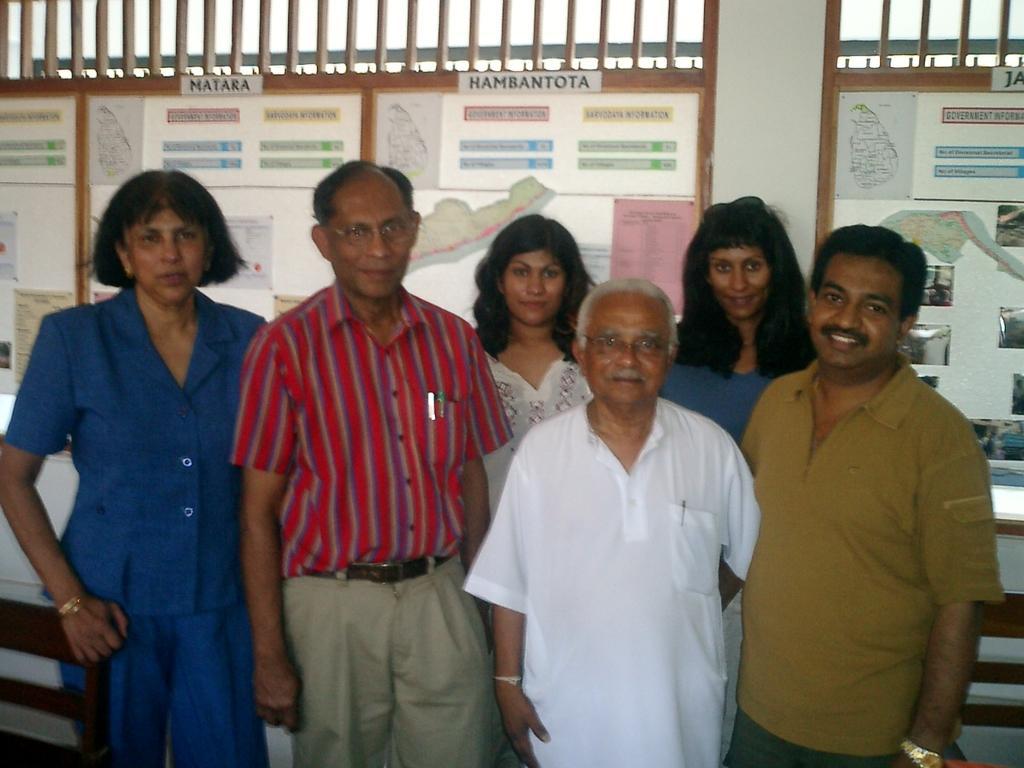Could you give a brief overview of what you see in this image? In this image we can see some people standing and in the background there is a wall with some text. 